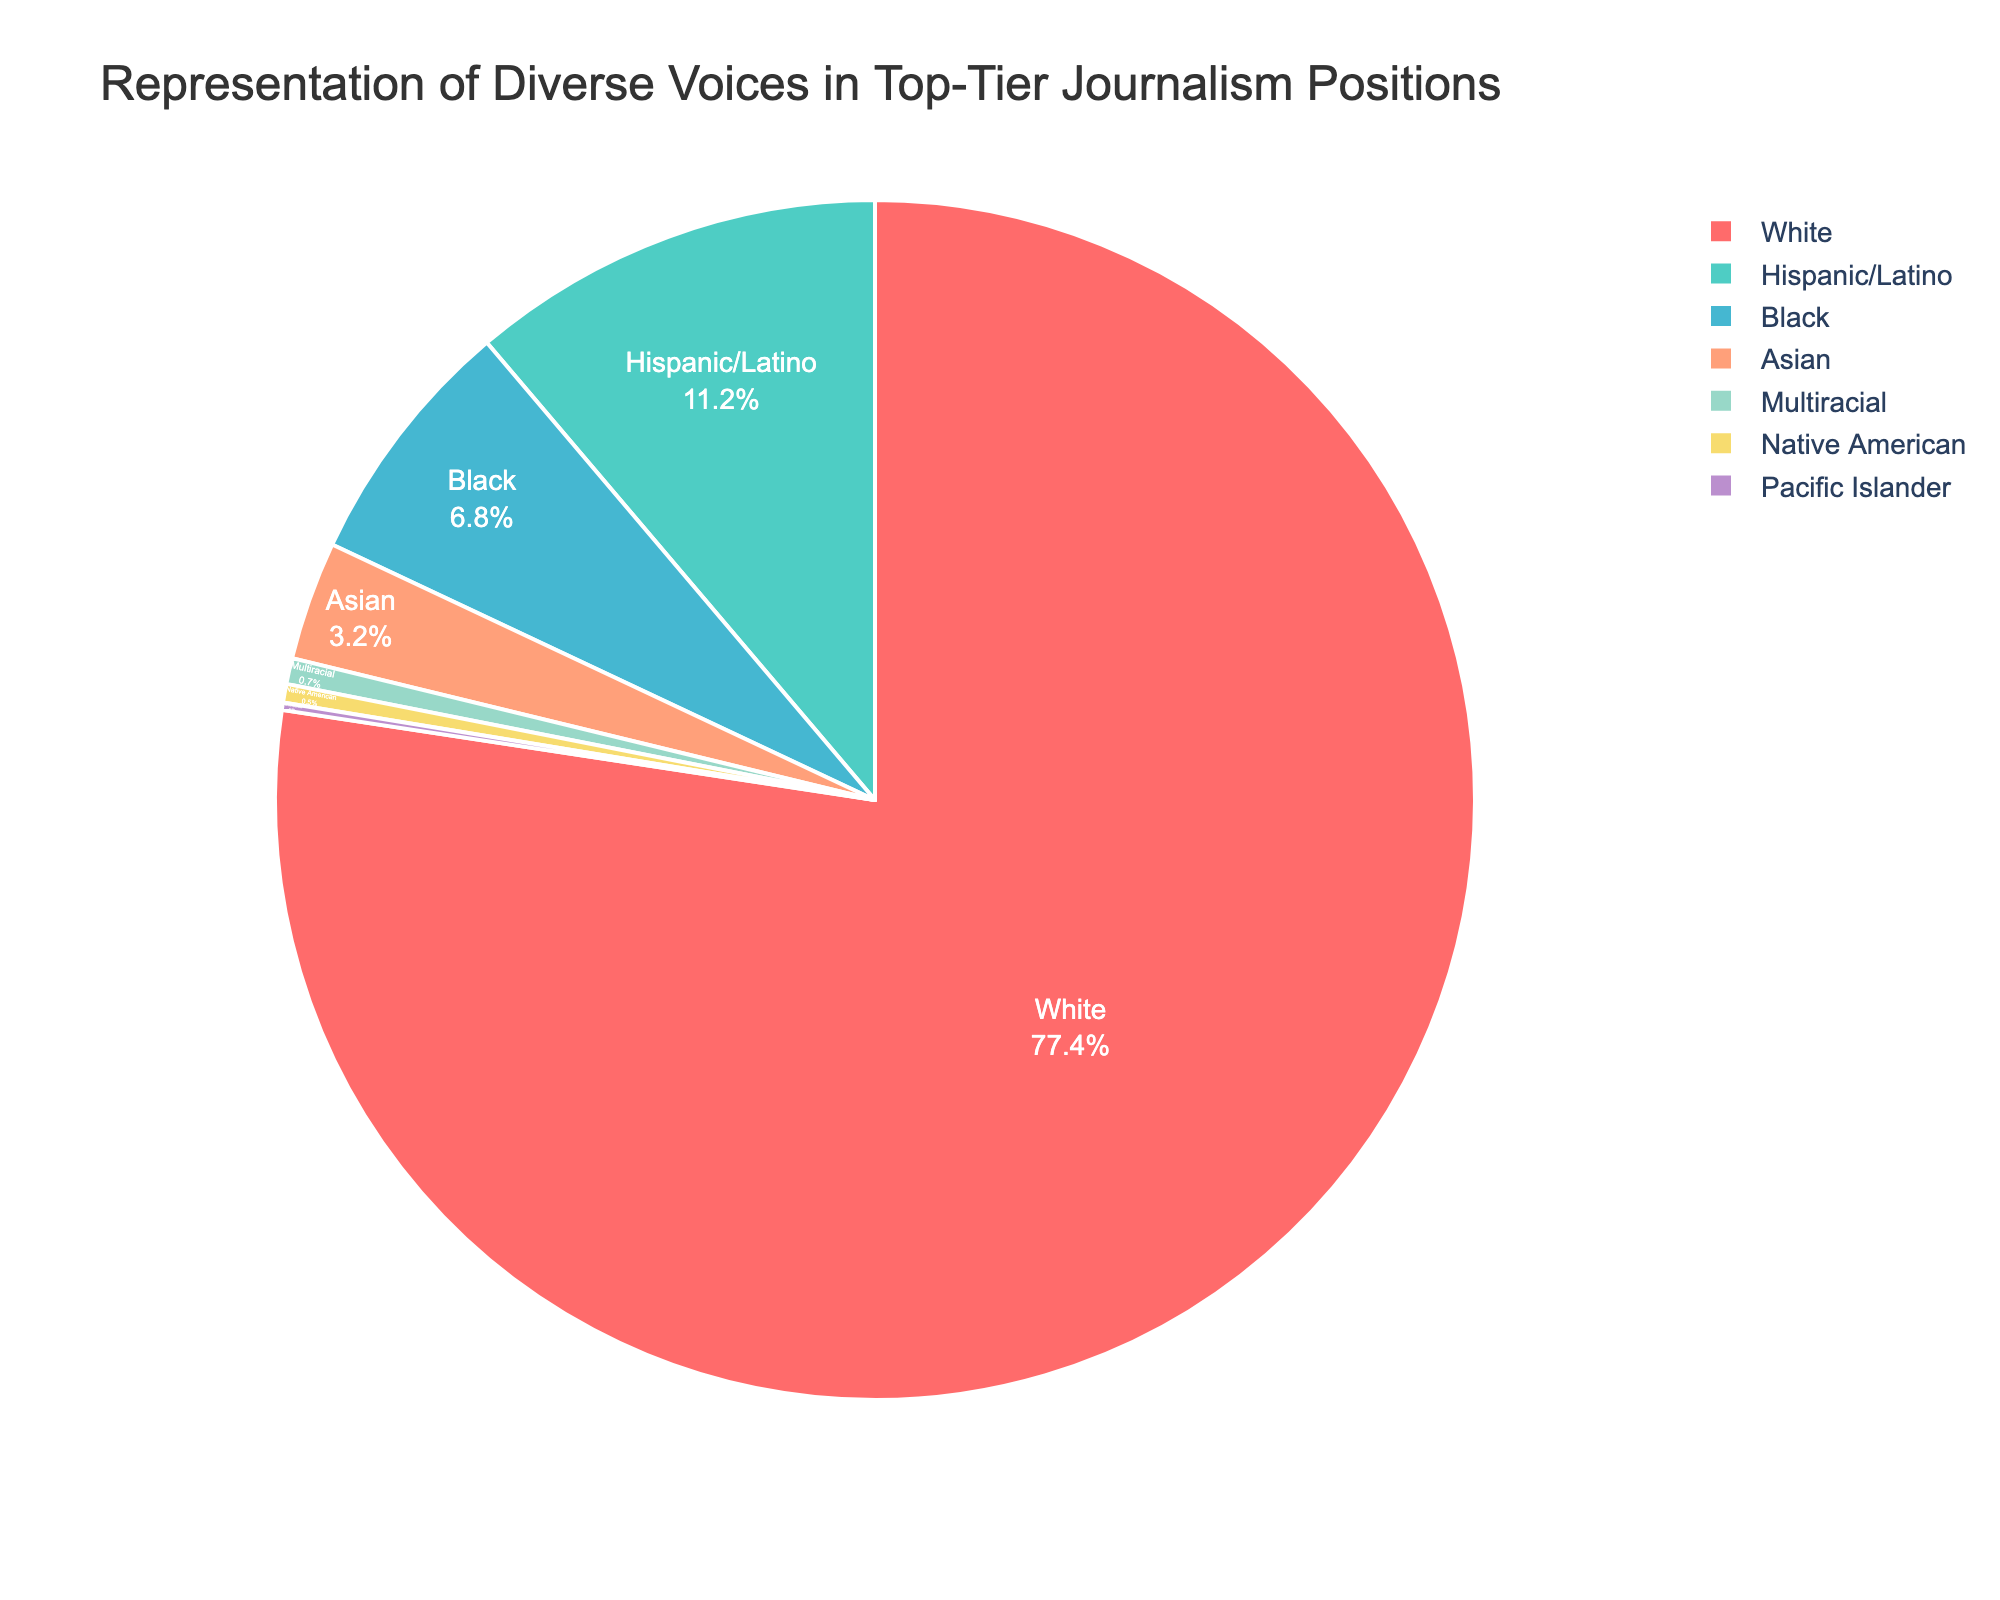What percentage of top-tier journalism positions do White individuals occupy? By examining the pie chart, observe the section labeled 'White' and note the associated percentage. This value shows the representation of White individuals.
Answer: 77.4% What's the combined percentage of Hispanic/Latino and Black individuals in top-tier journalism positions? Identify the percentage for Hispanic/Latino (11.2%) and Black (6.8%) on the pie chart. Add these values together: 11.2 + 6.8 = 18.
Answer: 18% How does the representation of Asian individuals compare to that of Native American individuals? Look at the percentages of Asian (3.2%) and Native American (0.5%) sections. Asian representation is greater.
Answer: Asian representation is greater What is the least represented race/ethnicity according to the pie chart? Locate the segment with the smallest percentage. The smallest value is for Pacific Islander, with 0.2%.
Answer: Pacific Islander Which group has a lower representation: Multiracial or Black individuals? Compare the percentages of Multiracial (0.7%) and Black (6.8%). Multiracial has a lower representation.
Answer: Multiracial Identify the color used for the Hispanic/Latino segment in the pie chart Look at the pie chart and identify the color corresponding to the Hispanic/Latino segment. The color is turquoise.
Answer: turquoise What is the difference in percentage between White and Asian representation? Determine the percentages for White (77.4%) and Asian (3.2%) groups. Subtract the smaller percentage from the larger one: 77.4 - 3.2 = 74.2.
Answer: 74.2% How does the sum of Native American, Pacific Islander, and Multiracial percentages compare to the Asian percentage? Sum the percentages for Native American (0.5%), Pacific Islander (0.2%), and Multiracial (0.7%): 0.5 + 0.2 + 0.7 = 1.4. Compare this sum (1.4) to the Asian percentage (3.2%). The sum of the three is smaller.
Answer: The sum is smaller Describe the visual difference between the section representing Black individuals and the section representing White individuals in terms of size. The pie chart’s section for Black individuals (6.8%) is significantly smaller than the section for White individuals (77.4%), showing the disparity in representation.
Answer: The White section is significantly larger What is the combined percentage of all non-White groups? Add the percentages of all groups other than White: Hispanic/Latino (11.2), Black (6.8), Asian (3.2), Native American (0.5), Pacific Islander (0.2), and Multiracial (0.7). Calculation: 11.2 + 6.8 + 3.2 + 0.5 + 0.2 + 0.7 = 22.6%.
Answer: 22.6% 